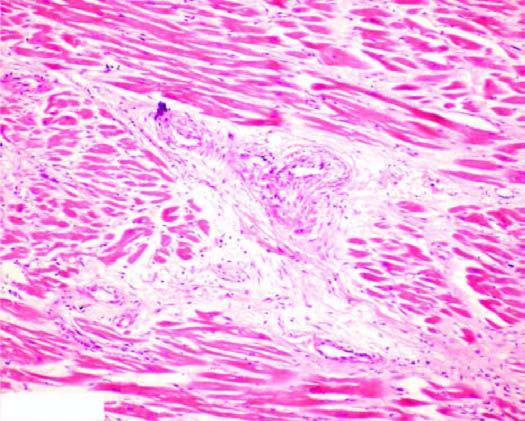what is there?
Answer the question using a single word or phrase. Patchy myocardial fibrosis 